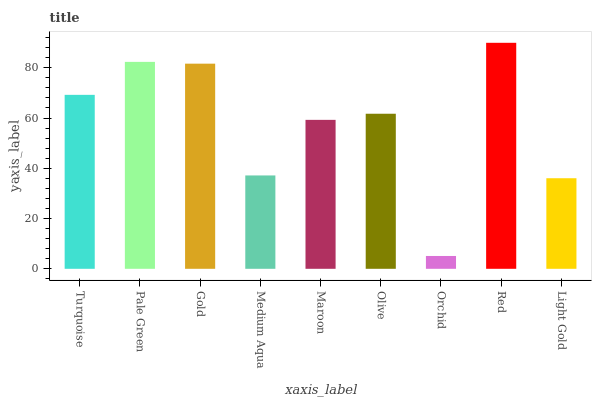Is Orchid the minimum?
Answer yes or no. Yes. Is Red the maximum?
Answer yes or no. Yes. Is Pale Green the minimum?
Answer yes or no. No. Is Pale Green the maximum?
Answer yes or no. No. Is Pale Green greater than Turquoise?
Answer yes or no. Yes. Is Turquoise less than Pale Green?
Answer yes or no. Yes. Is Turquoise greater than Pale Green?
Answer yes or no. No. Is Pale Green less than Turquoise?
Answer yes or no. No. Is Olive the high median?
Answer yes or no. Yes. Is Olive the low median?
Answer yes or no. Yes. Is Red the high median?
Answer yes or no. No. Is Pale Green the low median?
Answer yes or no. No. 